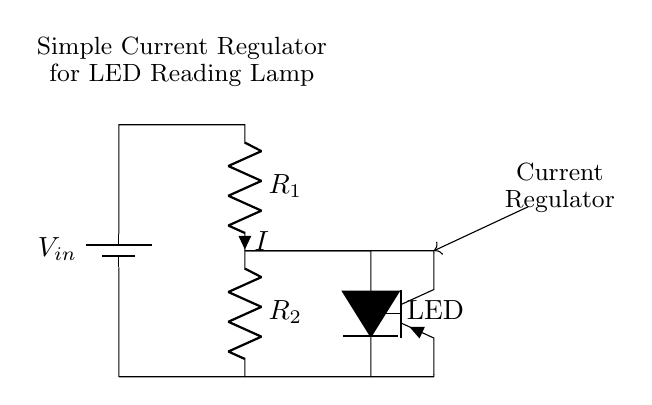What is the input voltage in this circuit? The input voltage is represented by the component labeled V_in. It is indicated at the top of the circuit diagram, showing where the power supply is connected.
Answer: V_in What type of regulator is shown in the circuit? The circuit features a current regulator, as indicated by the labeling adjacent to the current regulating component. This type of circuit is designed specifically to maintain a consistent current flow.
Answer: Current Regulator What is the function of the LED in this circuit? The LED acts as the load in this regulator circuit. It is connected in such a way that the current regulator ensures consistent brightness by maintaining a stable current through the LED, regardless of the supply voltage variations.
Answer: To maintain consistent brightness How many resistors are present in the circuit? The circuit has two resistors indicated by R_1 and R_2. These resistors are critical in determining the current flowing through the LED as well as affecting the operation of the PNP transistor.
Answer: Two resistors What component controls the current in the circuit? The component controlling the current is the PNP transistor, which adjusts the current flowing through the circuit based on the voltage drop across the resistors and the LED. This helps maintain the desired output current.
Answer: PNP transistor What happens to the brightness of the LED if V_in increases? If V_in increases, the current regulator will adjust the operation of the PNP transistor to ensure that the current through the LED remains constant. Thus, the brightness of the LED will not change significantly even if V_in increases, thanks to the regulator's function.
Answer: Brightness remains constant 